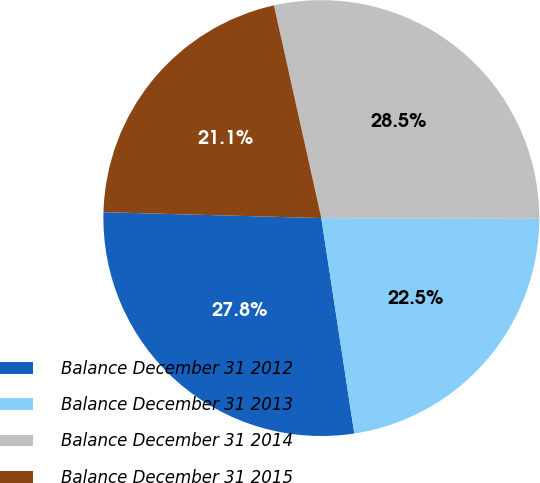<chart> <loc_0><loc_0><loc_500><loc_500><pie_chart><fcel>Balance December 31 2012<fcel>Balance December 31 2013<fcel>Balance December 31 2014<fcel>Balance December 31 2015<nl><fcel>27.85%<fcel>22.53%<fcel>28.54%<fcel>21.08%<nl></chart> 